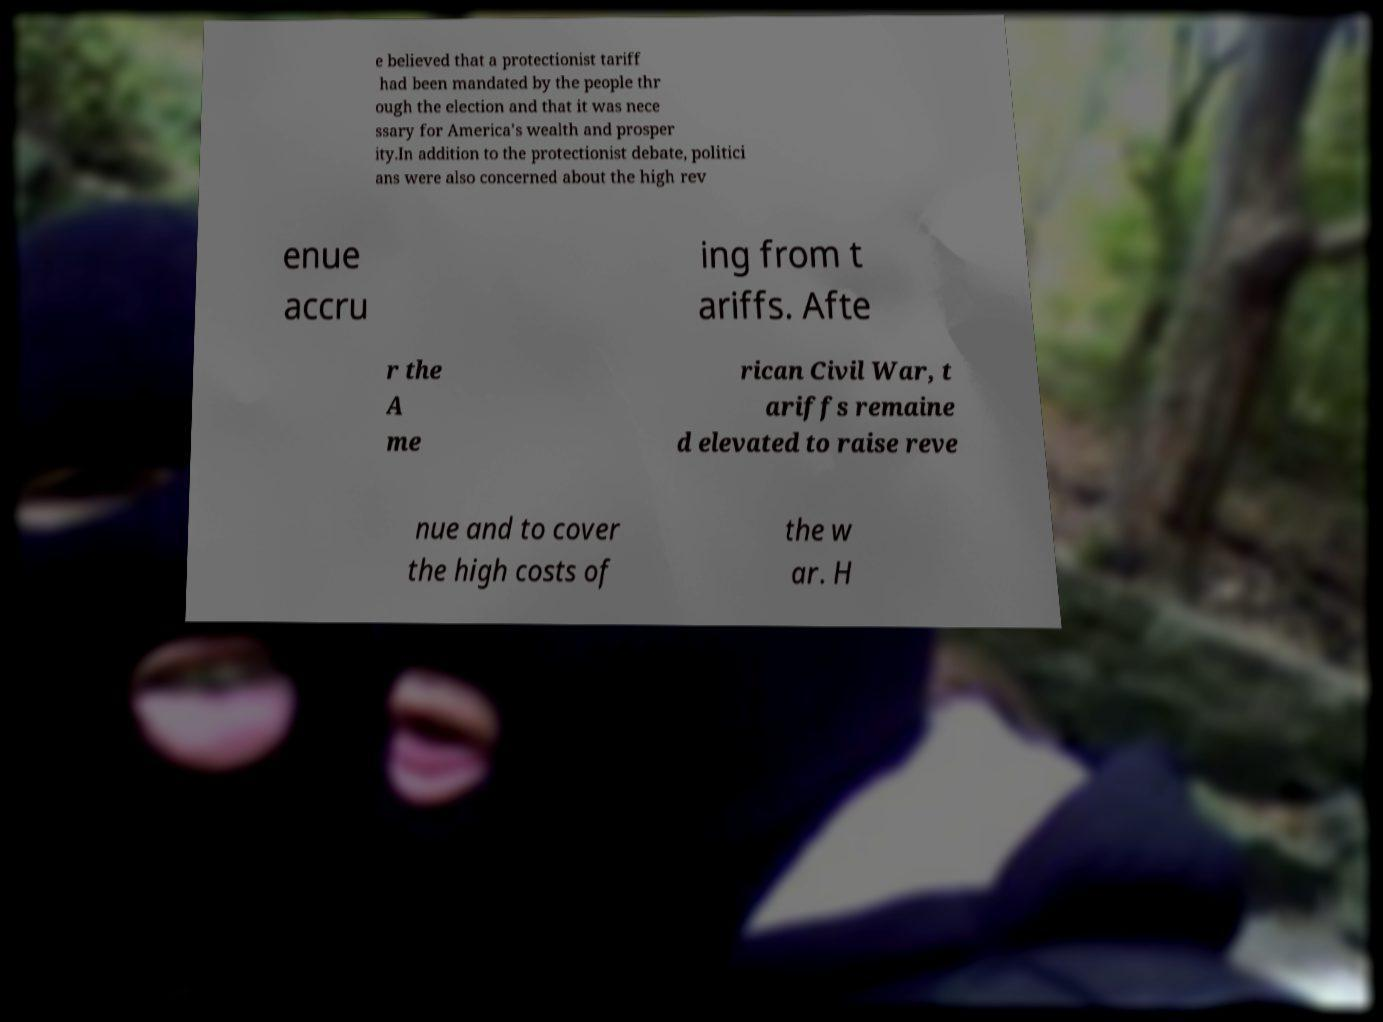Can you read and provide the text displayed in the image?This photo seems to have some interesting text. Can you extract and type it out for me? e believed that a protectionist tariff had been mandated by the people thr ough the election and that it was nece ssary for America's wealth and prosper ity.In addition to the protectionist debate, politici ans were also concerned about the high rev enue accru ing from t ariffs. Afte r the A me rican Civil War, t ariffs remaine d elevated to raise reve nue and to cover the high costs of the w ar. H 